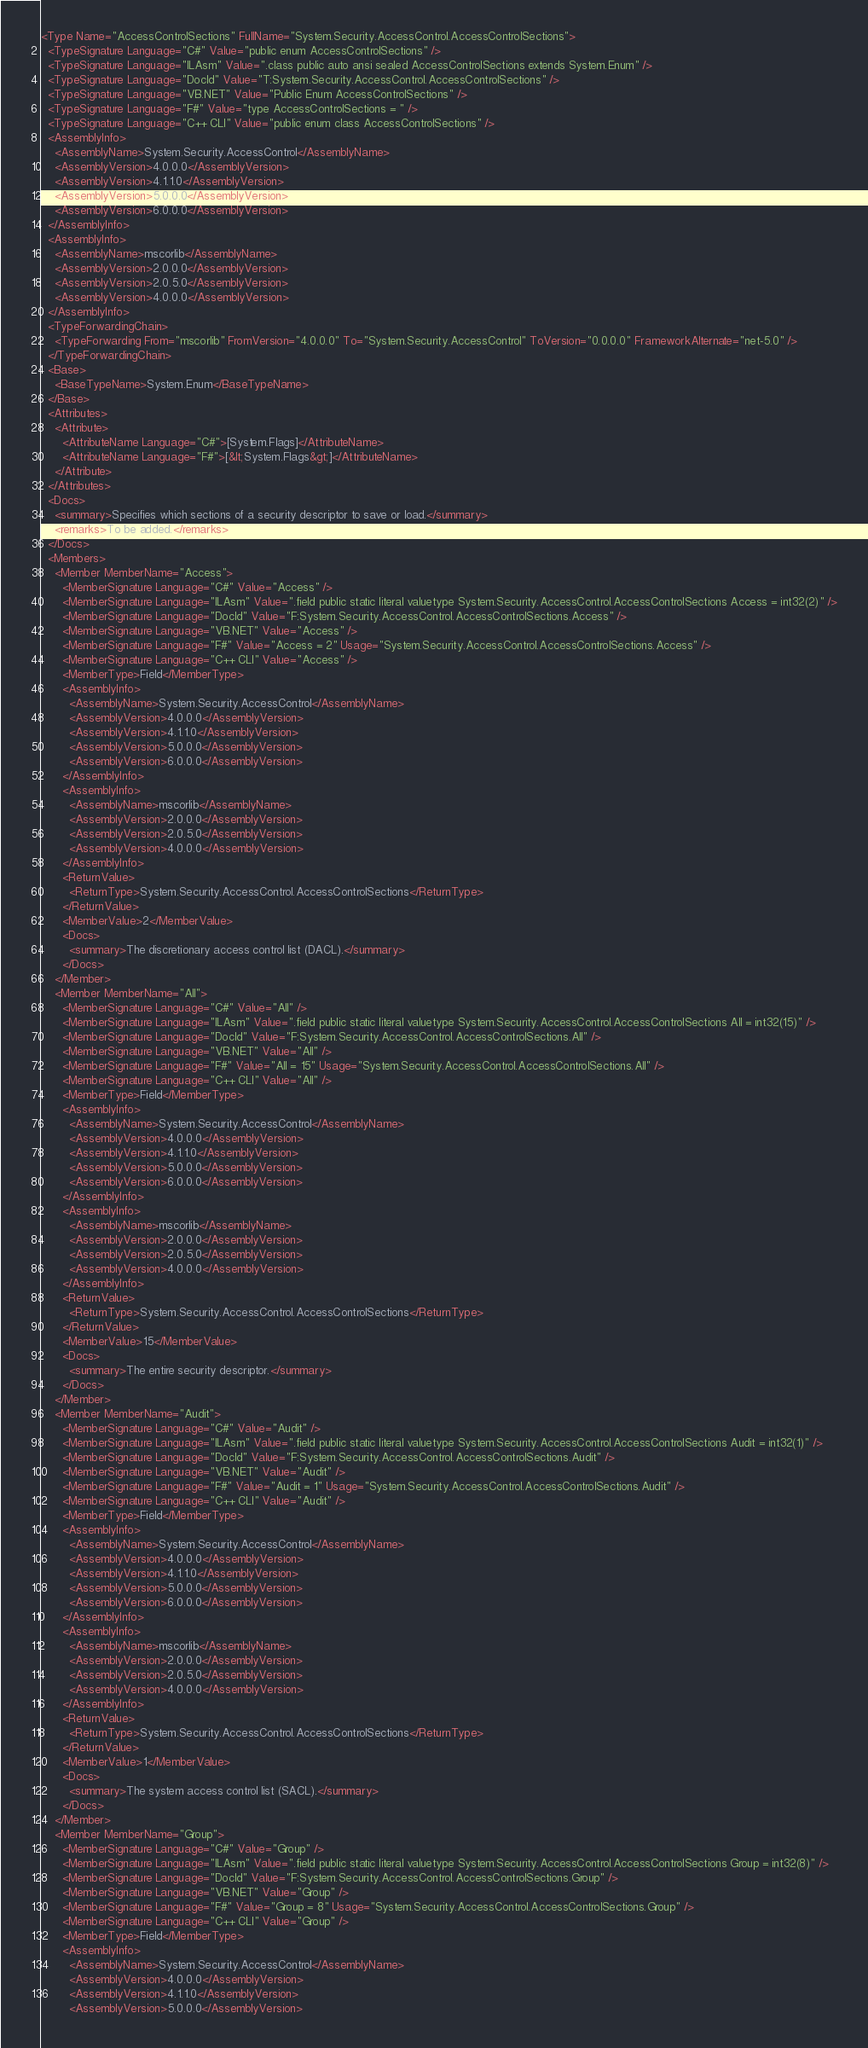Convert code to text. <code><loc_0><loc_0><loc_500><loc_500><_XML_><Type Name="AccessControlSections" FullName="System.Security.AccessControl.AccessControlSections">
  <TypeSignature Language="C#" Value="public enum AccessControlSections" />
  <TypeSignature Language="ILAsm" Value=".class public auto ansi sealed AccessControlSections extends System.Enum" />
  <TypeSignature Language="DocId" Value="T:System.Security.AccessControl.AccessControlSections" />
  <TypeSignature Language="VB.NET" Value="Public Enum AccessControlSections" />
  <TypeSignature Language="F#" Value="type AccessControlSections = " />
  <TypeSignature Language="C++ CLI" Value="public enum class AccessControlSections" />
  <AssemblyInfo>
    <AssemblyName>System.Security.AccessControl</AssemblyName>
    <AssemblyVersion>4.0.0.0</AssemblyVersion>
    <AssemblyVersion>4.1.1.0</AssemblyVersion>
    <AssemblyVersion>5.0.0.0</AssemblyVersion>
    <AssemblyVersion>6.0.0.0</AssemblyVersion>
  </AssemblyInfo>
  <AssemblyInfo>
    <AssemblyName>mscorlib</AssemblyName>
    <AssemblyVersion>2.0.0.0</AssemblyVersion>
    <AssemblyVersion>2.0.5.0</AssemblyVersion>
    <AssemblyVersion>4.0.0.0</AssemblyVersion>
  </AssemblyInfo>
  <TypeForwardingChain>
    <TypeForwarding From="mscorlib" FromVersion="4.0.0.0" To="System.Security.AccessControl" ToVersion="0.0.0.0" FrameworkAlternate="net-5.0" />
  </TypeForwardingChain>
  <Base>
    <BaseTypeName>System.Enum</BaseTypeName>
  </Base>
  <Attributes>
    <Attribute>
      <AttributeName Language="C#">[System.Flags]</AttributeName>
      <AttributeName Language="F#">[&lt;System.Flags&gt;]</AttributeName>
    </Attribute>
  </Attributes>
  <Docs>
    <summary>Specifies which sections of a security descriptor to save or load.</summary>
    <remarks>To be added.</remarks>
  </Docs>
  <Members>
    <Member MemberName="Access">
      <MemberSignature Language="C#" Value="Access" />
      <MemberSignature Language="ILAsm" Value=".field public static literal valuetype System.Security.AccessControl.AccessControlSections Access = int32(2)" />
      <MemberSignature Language="DocId" Value="F:System.Security.AccessControl.AccessControlSections.Access" />
      <MemberSignature Language="VB.NET" Value="Access" />
      <MemberSignature Language="F#" Value="Access = 2" Usage="System.Security.AccessControl.AccessControlSections.Access" />
      <MemberSignature Language="C++ CLI" Value="Access" />
      <MemberType>Field</MemberType>
      <AssemblyInfo>
        <AssemblyName>System.Security.AccessControl</AssemblyName>
        <AssemblyVersion>4.0.0.0</AssemblyVersion>
        <AssemblyVersion>4.1.1.0</AssemblyVersion>
        <AssemblyVersion>5.0.0.0</AssemblyVersion>
        <AssemblyVersion>6.0.0.0</AssemblyVersion>
      </AssemblyInfo>
      <AssemblyInfo>
        <AssemblyName>mscorlib</AssemblyName>
        <AssemblyVersion>2.0.0.0</AssemblyVersion>
        <AssemblyVersion>2.0.5.0</AssemblyVersion>
        <AssemblyVersion>4.0.0.0</AssemblyVersion>
      </AssemblyInfo>
      <ReturnValue>
        <ReturnType>System.Security.AccessControl.AccessControlSections</ReturnType>
      </ReturnValue>
      <MemberValue>2</MemberValue>
      <Docs>
        <summary>The discretionary access control list (DACL).</summary>
      </Docs>
    </Member>
    <Member MemberName="All">
      <MemberSignature Language="C#" Value="All" />
      <MemberSignature Language="ILAsm" Value=".field public static literal valuetype System.Security.AccessControl.AccessControlSections All = int32(15)" />
      <MemberSignature Language="DocId" Value="F:System.Security.AccessControl.AccessControlSections.All" />
      <MemberSignature Language="VB.NET" Value="All" />
      <MemberSignature Language="F#" Value="All = 15" Usage="System.Security.AccessControl.AccessControlSections.All" />
      <MemberSignature Language="C++ CLI" Value="All" />
      <MemberType>Field</MemberType>
      <AssemblyInfo>
        <AssemblyName>System.Security.AccessControl</AssemblyName>
        <AssemblyVersion>4.0.0.0</AssemblyVersion>
        <AssemblyVersion>4.1.1.0</AssemblyVersion>
        <AssemblyVersion>5.0.0.0</AssemblyVersion>
        <AssemblyVersion>6.0.0.0</AssemblyVersion>
      </AssemblyInfo>
      <AssemblyInfo>
        <AssemblyName>mscorlib</AssemblyName>
        <AssemblyVersion>2.0.0.0</AssemblyVersion>
        <AssemblyVersion>2.0.5.0</AssemblyVersion>
        <AssemblyVersion>4.0.0.0</AssemblyVersion>
      </AssemblyInfo>
      <ReturnValue>
        <ReturnType>System.Security.AccessControl.AccessControlSections</ReturnType>
      </ReturnValue>
      <MemberValue>15</MemberValue>
      <Docs>
        <summary>The entire security descriptor.</summary>
      </Docs>
    </Member>
    <Member MemberName="Audit">
      <MemberSignature Language="C#" Value="Audit" />
      <MemberSignature Language="ILAsm" Value=".field public static literal valuetype System.Security.AccessControl.AccessControlSections Audit = int32(1)" />
      <MemberSignature Language="DocId" Value="F:System.Security.AccessControl.AccessControlSections.Audit" />
      <MemberSignature Language="VB.NET" Value="Audit" />
      <MemberSignature Language="F#" Value="Audit = 1" Usage="System.Security.AccessControl.AccessControlSections.Audit" />
      <MemberSignature Language="C++ CLI" Value="Audit" />
      <MemberType>Field</MemberType>
      <AssemblyInfo>
        <AssemblyName>System.Security.AccessControl</AssemblyName>
        <AssemblyVersion>4.0.0.0</AssemblyVersion>
        <AssemblyVersion>4.1.1.0</AssemblyVersion>
        <AssemblyVersion>5.0.0.0</AssemblyVersion>
        <AssemblyVersion>6.0.0.0</AssemblyVersion>
      </AssemblyInfo>
      <AssemblyInfo>
        <AssemblyName>mscorlib</AssemblyName>
        <AssemblyVersion>2.0.0.0</AssemblyVersion>
        <AssemblyVersion>2.0.5.0</AssemblyVersion>
        <AssemblyVersion>4.0.0.0</AssemblyVersion>
      </AssemblyInfo>
      <ReturnValue>
        <ReturnType>System.Security.AccessControl.AccessControlSections</ReturnType>
      </ReturnValue>
      <MemberValue>1</MemberValue>
      <Docs>
        <summary>The system access control list (SACL).</summary>
      </Docs>
    </Member>
    <Member MemberName="Group">
      <MemberSignature Language="C#" Value="Group" />
      <MemberSignature Language="ILAsm" Value=".field public static literal valuetype System.Security.AccessControl.AccessControlSections Group = int32(8)" />
      <MemberSignature Language="DocId" Value="F:System.Security.AccessControl.AccessControlSections.Group" />
      <MemberSignature Language="VB.NET" Value="Group" />
      <MemberSignature Language="F#" Value="Group = 8" Usage="System.Security.AccessControl.AccessControlSections.Group" />
      <MemberSignature Language="C++ CLI" Value="Group" />
      <MemberType>Field</MemberType>
      <AssemblyInfo>
        <AssemblyName>System.Security.AccessControl</AssemblyName>
        <AssemblyVersion>4.0.0.0</AssemblyVersion>
        <AssemblyVersion>4.1.1.0</AssemblyVersion>
        <AssemblyVersion>5.0.0.0</AssemblyVersion></code> 